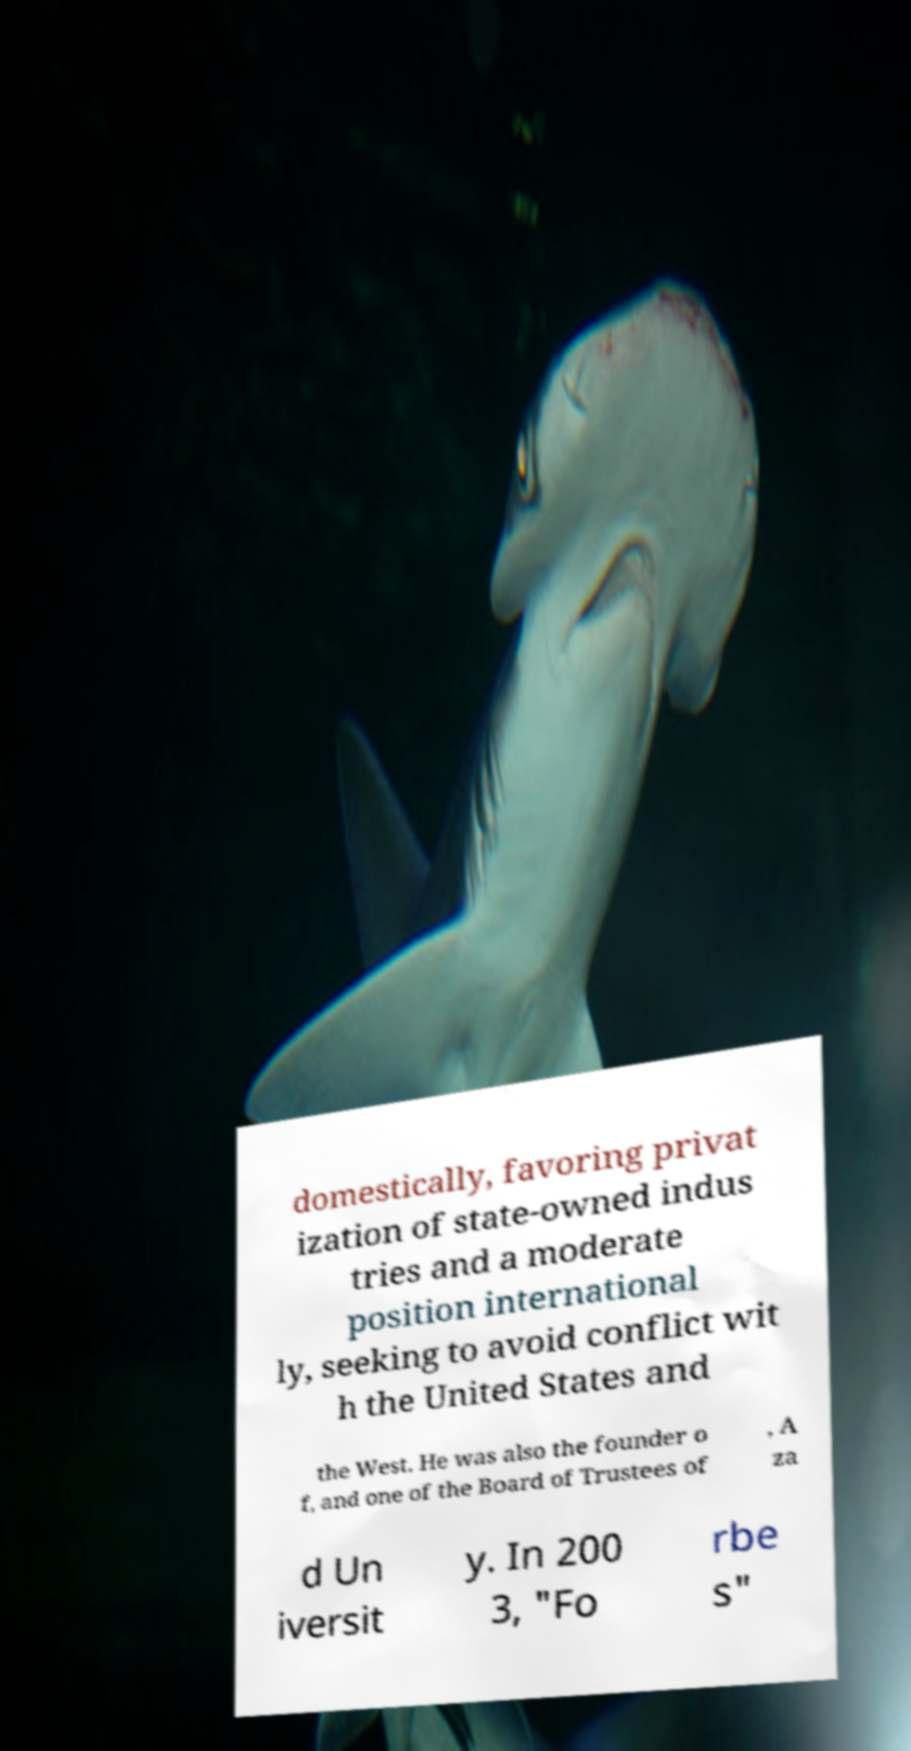For documentation purposes, I need the text within this image transcribed. Could you provide that? domestically, favoring privat ization of state-owned indus tries and a moderate position international ly, seeking to avoid conflict wit h the United States and the West. He was also the founder o f, and one of the Board of Trustees of , A za d Un iversit y. In 200 3, "Fo rbe s" 